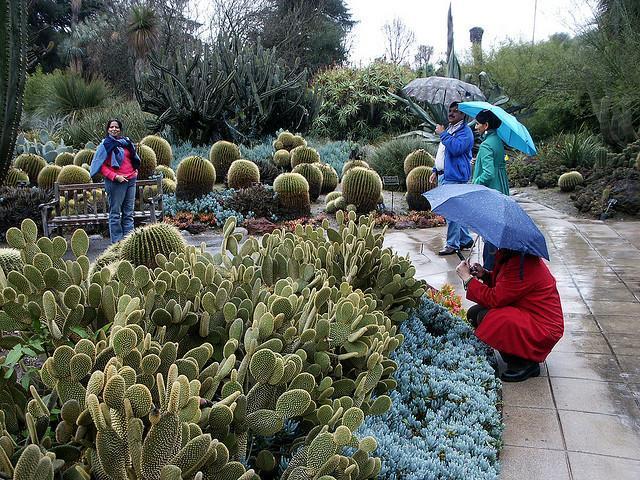How many people are visible?
Give a very brief answer. 4. 